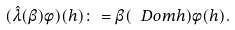Convert formula to latex. <formula><loc_0><loc_0><loc_500><loc_500>( \hat { \lambda } ( \beta ) \phi ) ( h ) \colon = \beta ( \ D o m { h } ) \phi ( h ) .</formula> 